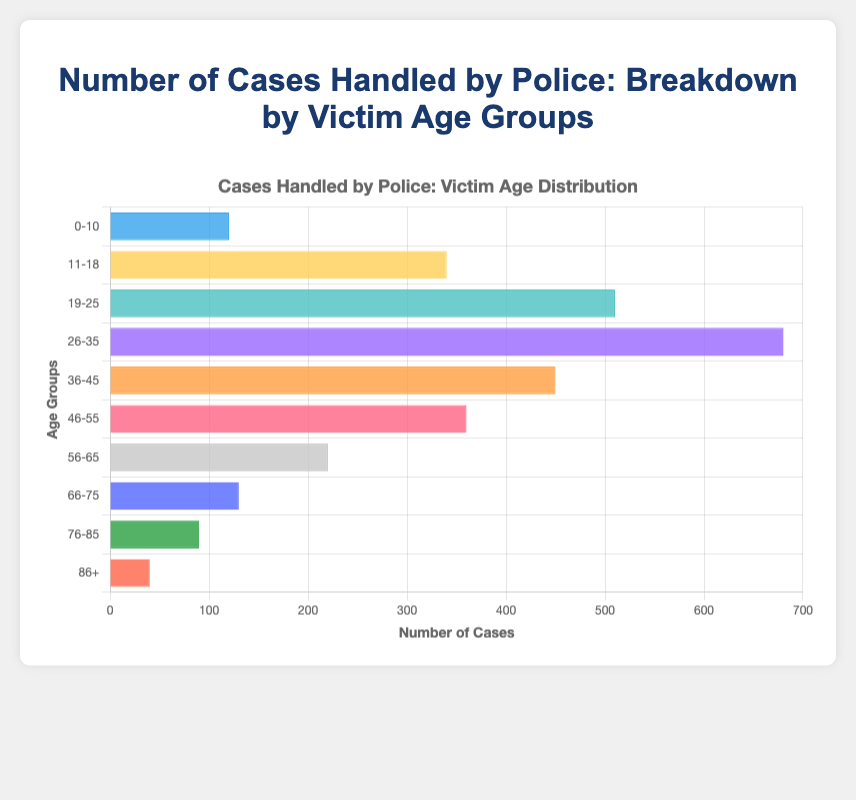Which age group has the highest number of cases handled by police? To determine which age group has the highest number of cases, look for the longest bar in the horizontal bar chart. The 26-35 age group has the longest bar.
Answer: 26-35 What is the total number of cases handled by the police for age groups 0-10 and 11-18 combined? Add the number of cases for the 0-10 and 11-18 age groups: 120 (0-10) + 340 (11-18) = 460.
Answer: 460 Which age group has fewer cases handled by police than the 46-55 age group but more than the 66-75 age group? Compare the number of cases for the age groups: 66-75 (130 cases), 46-55 (360 cases), and 56-65 (220 cases). The 56-65 age group fits the criteria.
Answer: 56-65 By how many cases does the 26-35 age group exceed the 19-25 age group in cases handled by the police? Subtract the number of cases in the 19-25 group from the 26-35 group: 680 (26-35) - 510 (19-25) = 170.
Answer: 170 Which age group has the second-highest number of cases handled by police? Identify the second longest bar in the chart after the 26-35 age group. The 19-25 age group has the second-longest bar.
Answer: 19-25 What is the average number of cases handled by police across all age groups? To find the average, sum the cases for all age groups and divide by the number of age groups. Total cases: 120+340+510+680+450+360+220+130+90+40 = 2940. Number of age groups: 10. Average = 2940 / 10 = 294.
Answer: 294 Which two age groups combined account for the highest number of cases handled by police? Add up the cases for all possible pairs and find the pair with the highest sum. The pair 19-25 (510) and 26-35 (680) gives the highest sum: 510 + 680 = 1190.
Answer: 19-25 and 26-35 What is the percentage of total cases handled by police for the 36-45 age group? Find the percentage by dividing the number of cases for the 36-45 group by the total number of cases: (450 / 2940) * 100 ≈ 15.31%.
Answer: 15.31% Which age group has the most similar number of cases handled by police as the 56-65 age group? Compare the cases for each age group to the 56-65 group (220 cases) and find the closest number. The 66-75 age group has 130 cases, which is closest to 220.
Answer: 66-75 